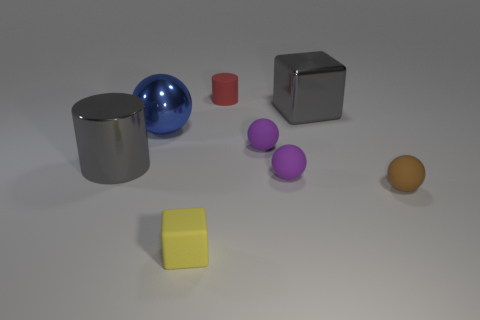Are the objects casting any shadows and what does that tell us about the light source? Yes, each object casts a shadow, indicating that the light source is above and slightly to the right of the scene. The shadows are soft-edged, suggesting the light is diffused, not a point source like the sun without clouds. 